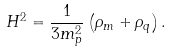<formula> <loc_0><loc_0><loc_500><loc_500>H ^ { 2 } = \frac { 1 } { 3 m _ { p } ^ { 2 } } \left ( \rho _ { m } + \rho _ { q } \right ) .</formula> 